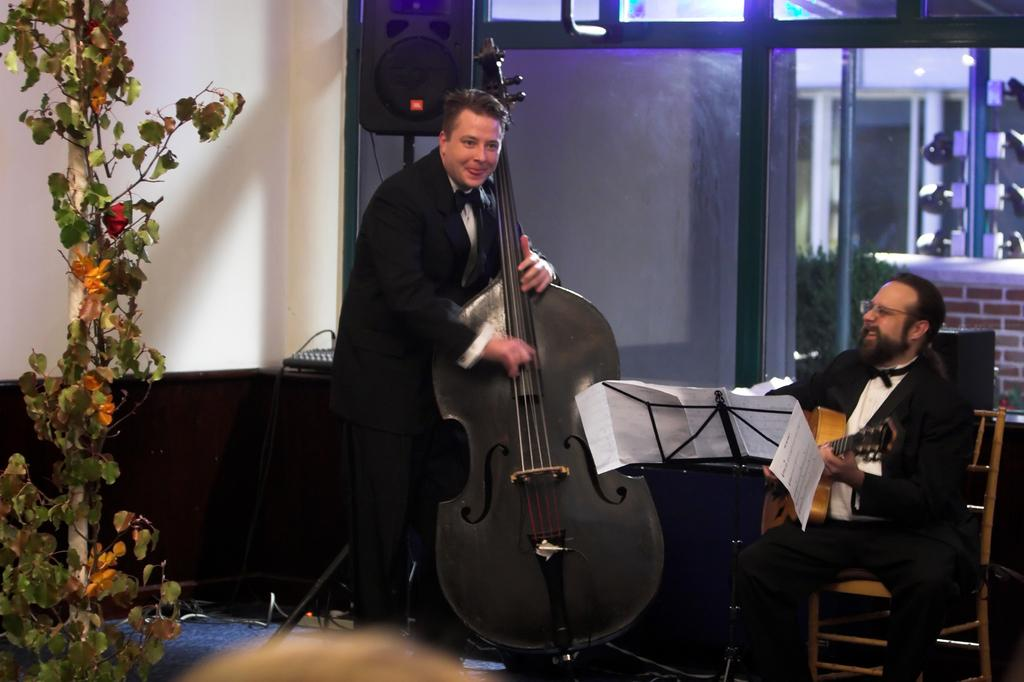What is the person on the left side of the image doing? The person on the left side of the image is playing the violin. What is the person on the right side of the image doing? The person on the right side of the image is sitting on a chair and playing the guitar. What can be seen in the background of the image? There is a plant, a wall, a speaker, and a glass door in the background of the image. What type of cabbage is being used as a drumstick by the person playing the guitar? There is no cabbage present in the image, and the person playing the guitar is using their hands or a guitar pick, not a cabbage, to play the instrument. 